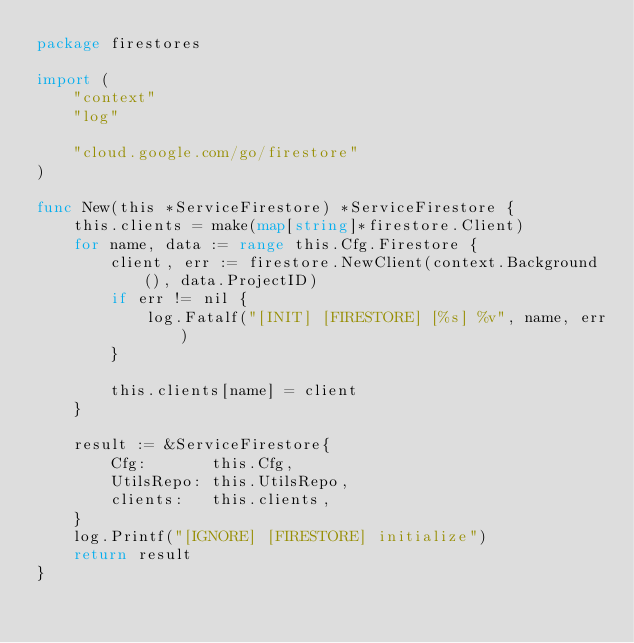<code> <loc_0><loc_0><loc_500><loc_500><_Go_>package firestores

import (
	"context"
	"log"

	"cloud.google.com/go/firestore"
)

func New(this *ServiceFirestore) *ServiceFirestore {
	this.clients = make(map[string]*firestore.Client)
	for name, data := range this.Cfg.Firestore {
		client, err := firestore.NewClient(context.Background(), data.ProjectID)
		if err != nil {
			log.Fatalf("[INIT] [FIRESTORE] [%s] %v", name, err)
		}

		this.clients[name] = client
	}

	result := &ServiceFirestore{
		Cfg:       this.Cfg,
		UtilsRepo: this.UtilsRepo,
		clients:   this.clients,
	}
	log.Printf("[IGNORE] [FIRESTORE] initialize")
	return result
}
</code> 